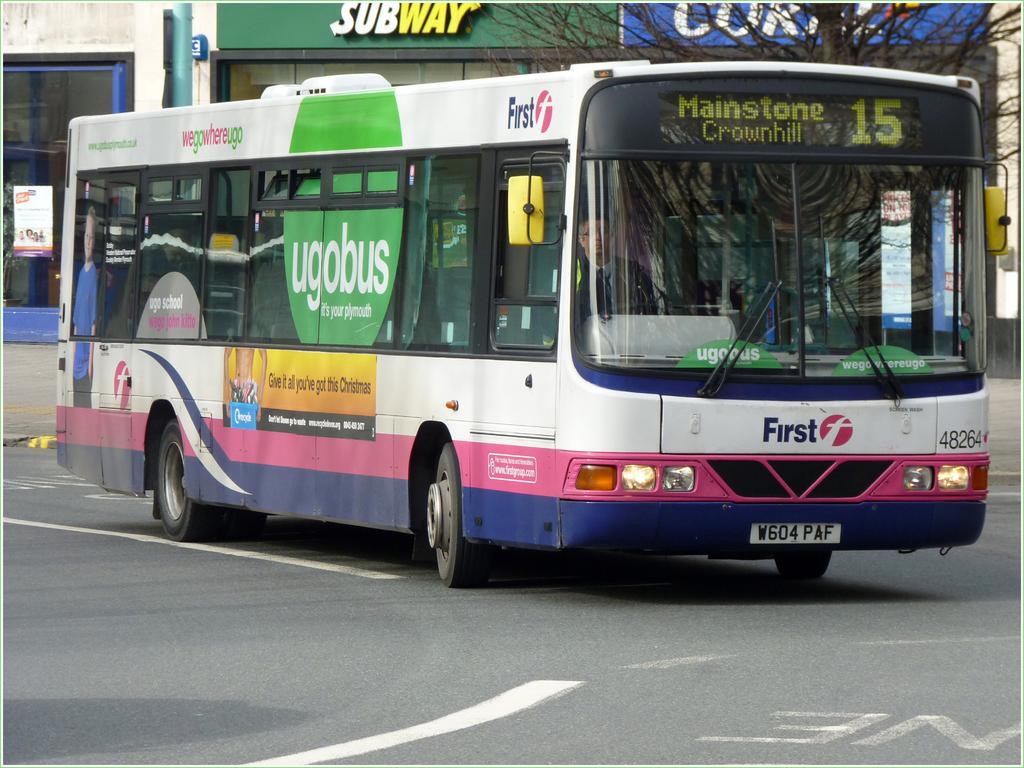What route does this bus take?
Give a very brief answer. 15. What does the license plate read?
Your answer should be compact. W604paf. 